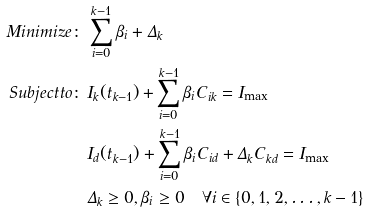Convert formula to latex. <formula><loc_0><loc_0><loc_500><loc_500>M i n i m i z e \colon \, & \sum _ { i = 0 } ^ { k - 1 } \beta _ { i } + \Delta _ { k } \\ S u b j e c t t o \colon \, & { I } _ { k } ( t _ { k - 1 } ) + \sum _ { i = 0 } ^ { k - 1 } \beta _ { i } C _ { i k } = { I } _ { \max } \\ & { I } _ { d } ( t _ { k - 1 } ) + \sum _ { i = 0 } ^ { k - 1 } \beta _ { i } C _ { i d } + \Delta _ { k } C _ { k d } = { I } _ { \max } \\ & \Delta _ { k } \geq 0 , \beta _ { i } \geq 0 \quad \forall i \in \{ 0 , 1 , 2 , \dots , k - 1 \}</formula> 